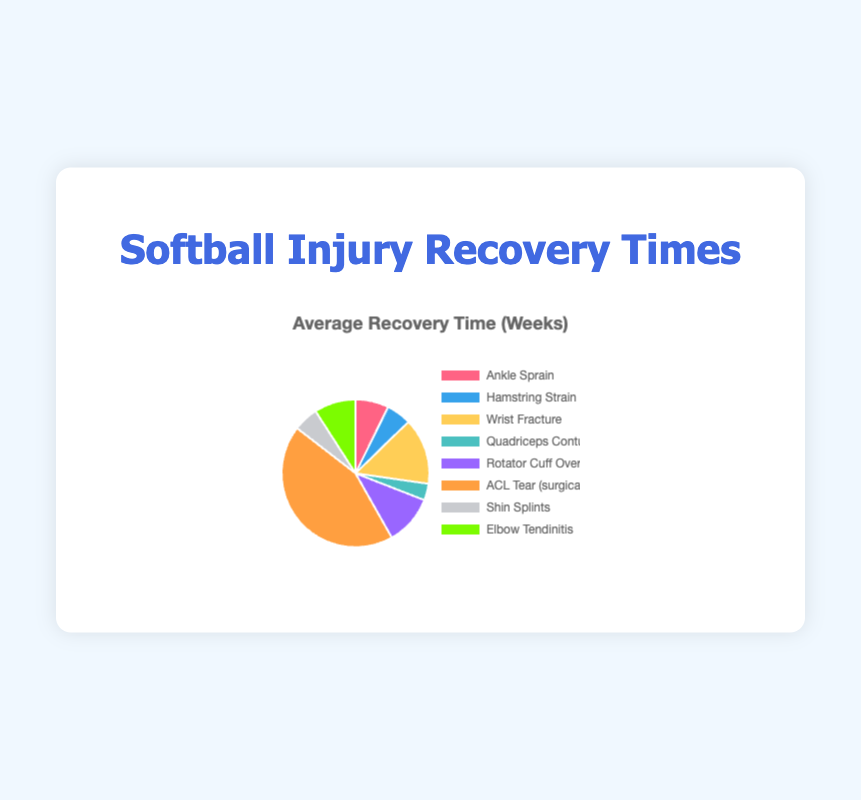What type of injury has the shortest average recovery time? By examining the pie chart, find the section with the smallest value. The injury with the shortest recovery time is Quadriceps Contusion, with an average recovery time of 2 weeks.
Answer: Quadriceps Contusion Which injury has the longest average recovery time? Look at the pie chart and identify the section with the largest value. The injury with the longest recovery time is an ACL Tear (surgical intervention), with an average recovery time of 24 weeks.
Answer: ACL Tear (surgical intervention) How many weeks of recovery are needed in total for a Hamstring Strain, Elbow Tendinitis, and Ankle Sprain? Sum the average recovery times for Hamstring Strain (3 weeks), Elbow Tendinitis (5 weeks), and Ankle Sprain (4 weeks). 3 + 5 + 4 = 12 weeks.
Answer: 12 weeks Which injuries require an average recovery time of more than 5 weeks? Find the segments of the pie chart where the recovery time is greater than 5 weeks, namely Wrist Fracture (8 weeks), Rotator Cuff Overuse Injury (6 weeks), ACL Tear (surgical intervention) (24 weeks), and Elbow Tendinitis (5 weeks).
Answer: Wrist Fracture, Rotator Cuff Overuse Injury, ACL Tear (surgical intervention), Elbow Tendinitis Is the recovery time for a Wrist Fracture less than the combined recovery times of Hamstring Strain and Shin Splints? Compare the average recovery time of a Wrist Fracture (8 weeks) with the sum of Hamstring Strain (3 weeks) and Shin Splints (3 weeks), 3 + 3 = 6 weeks. 8 weeks is greater than 6 weeks.
Answer: No What is the total recovery time for all injuries combined? Add the average recovery times of all injury types: 4 + 3 + 8 + 2 + 6 + 24 + 3 + 5 = 55 weeks.
Answer: 55 weeks Which recovery time is represented by the green section of the pie chart? By identifying the green color section in the pie chart, it corresponds to Shin Splints with a recovery time of 3 weeks.
Answer: Shin Splints Which injuries have an average recovery time of exactly 3 weeks? Locate the segments of the pie chart that show a recovery time of 3 weeks: Hamstring Strain and Shin Splints both fall into this category.
Answer: Hamstring Strain, Shin Splints If an athlete experiences both a Rotator Cuff Overuse Injury and Elbow Tendinitis, how many weeks of recovery are needed in total? Add the average recovery times for Rotator Cuff Overuse Injury (6 weeks) and Elbow Tendinitis (5 weeks): 6 + 5 = 11 weeks.
Answer: 11 weeks How does the recovery time for a Quadriceps Contusion compare to a Hamstring Strain? By comparing the average recovery times from the pie chart, the Quadriceps Contusion has a recovery time of 2 weeks and the Hamstring Strain has 3 weeks. 2 weeks is less than 3 weeks.
Answer: Less 